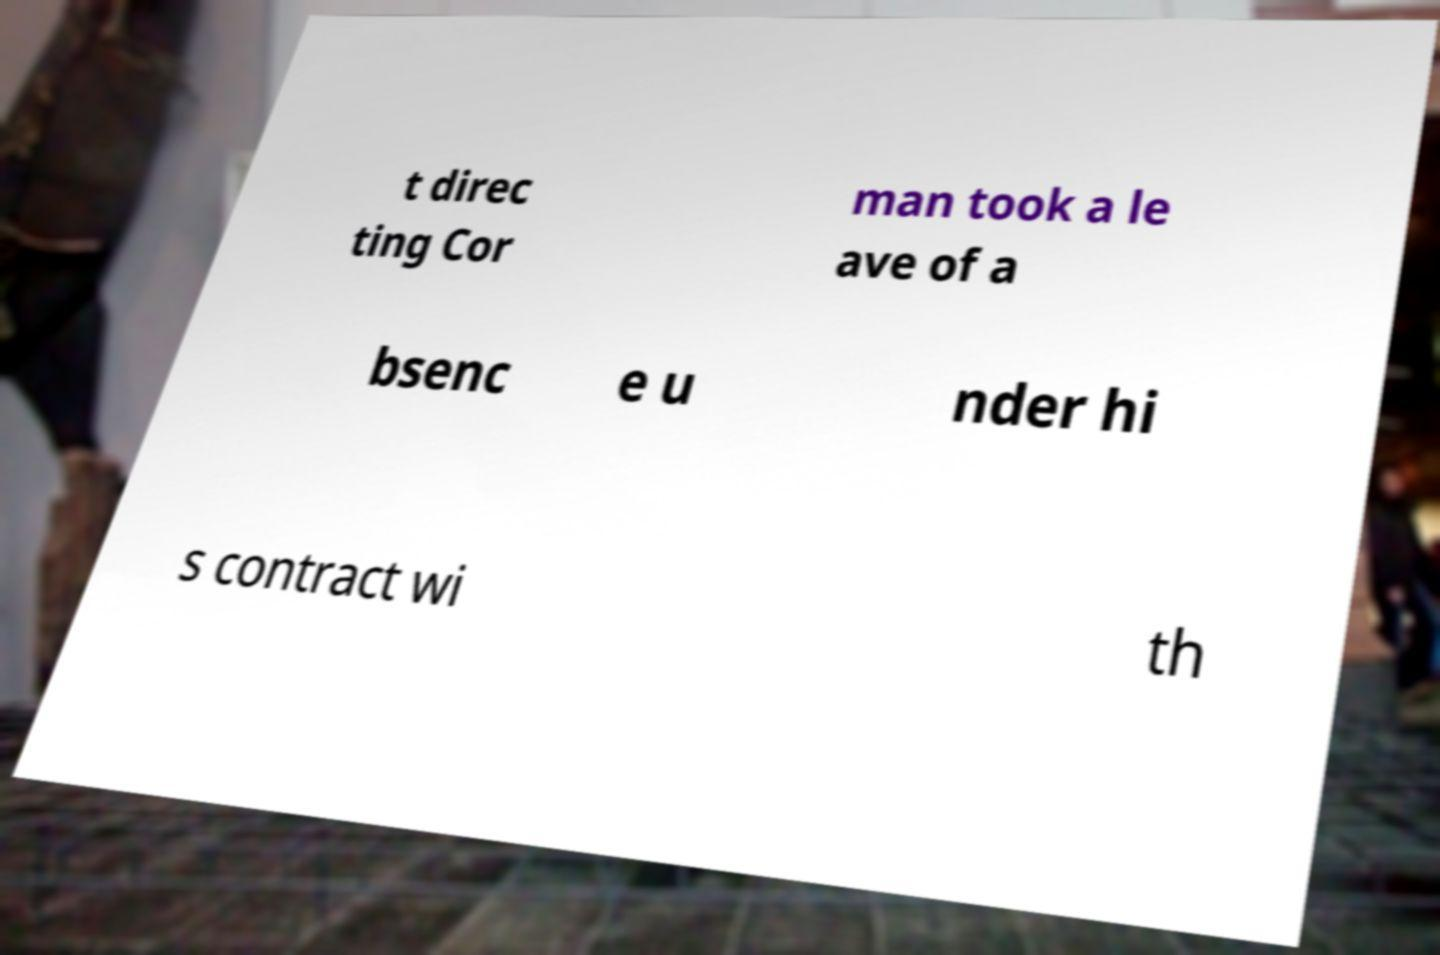Could you extract and type out the text from this image? t direc ting Cor man took a le ave of a bsenc e u nder hi s contract wi th 